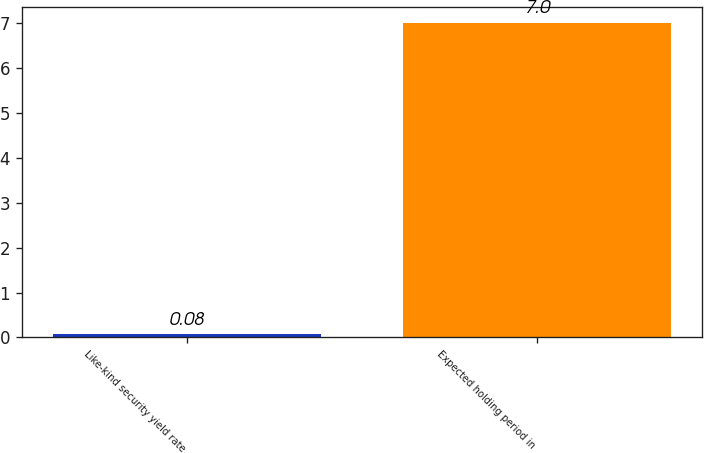Convert chart to OTSL. <chart><loc_0><loc_0><loc_500><loc_500><bar_chart><fcel>Like-kind security yield rate<fcel>Expected holding period in<nl><fcel>0.08<fcel>7<nl></chart> 